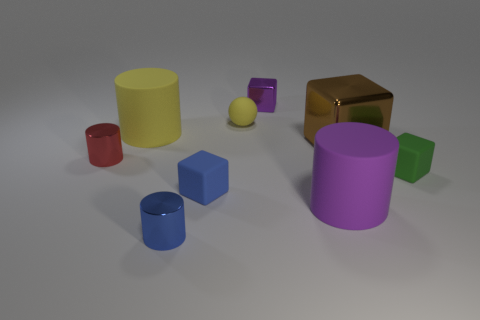Subtract all tiny cubes. How many cubes are left? 1 Subtract all blue blocks. How many blocks are left? 3 Subtract 1 yellow cylinders. How many objects are left? 8 Subtract all cubes. How many objects are left? 5 Subtract 3 cylinders. How many cylinders are left? 1 Subtract all cyan cylinders. Subtract all cyan cubes. How many cylinders are left? 4 Subtract all brown cylinders. How many red balls are left? 0 Subtract all tiny metallic cylinders. Subtract all big brown metallic things. How many objects are left? 6 Add 5 big yellow things. How many big yellow things are left? 6 Add 1 matte spheres. How many matte spheres exist? 2 